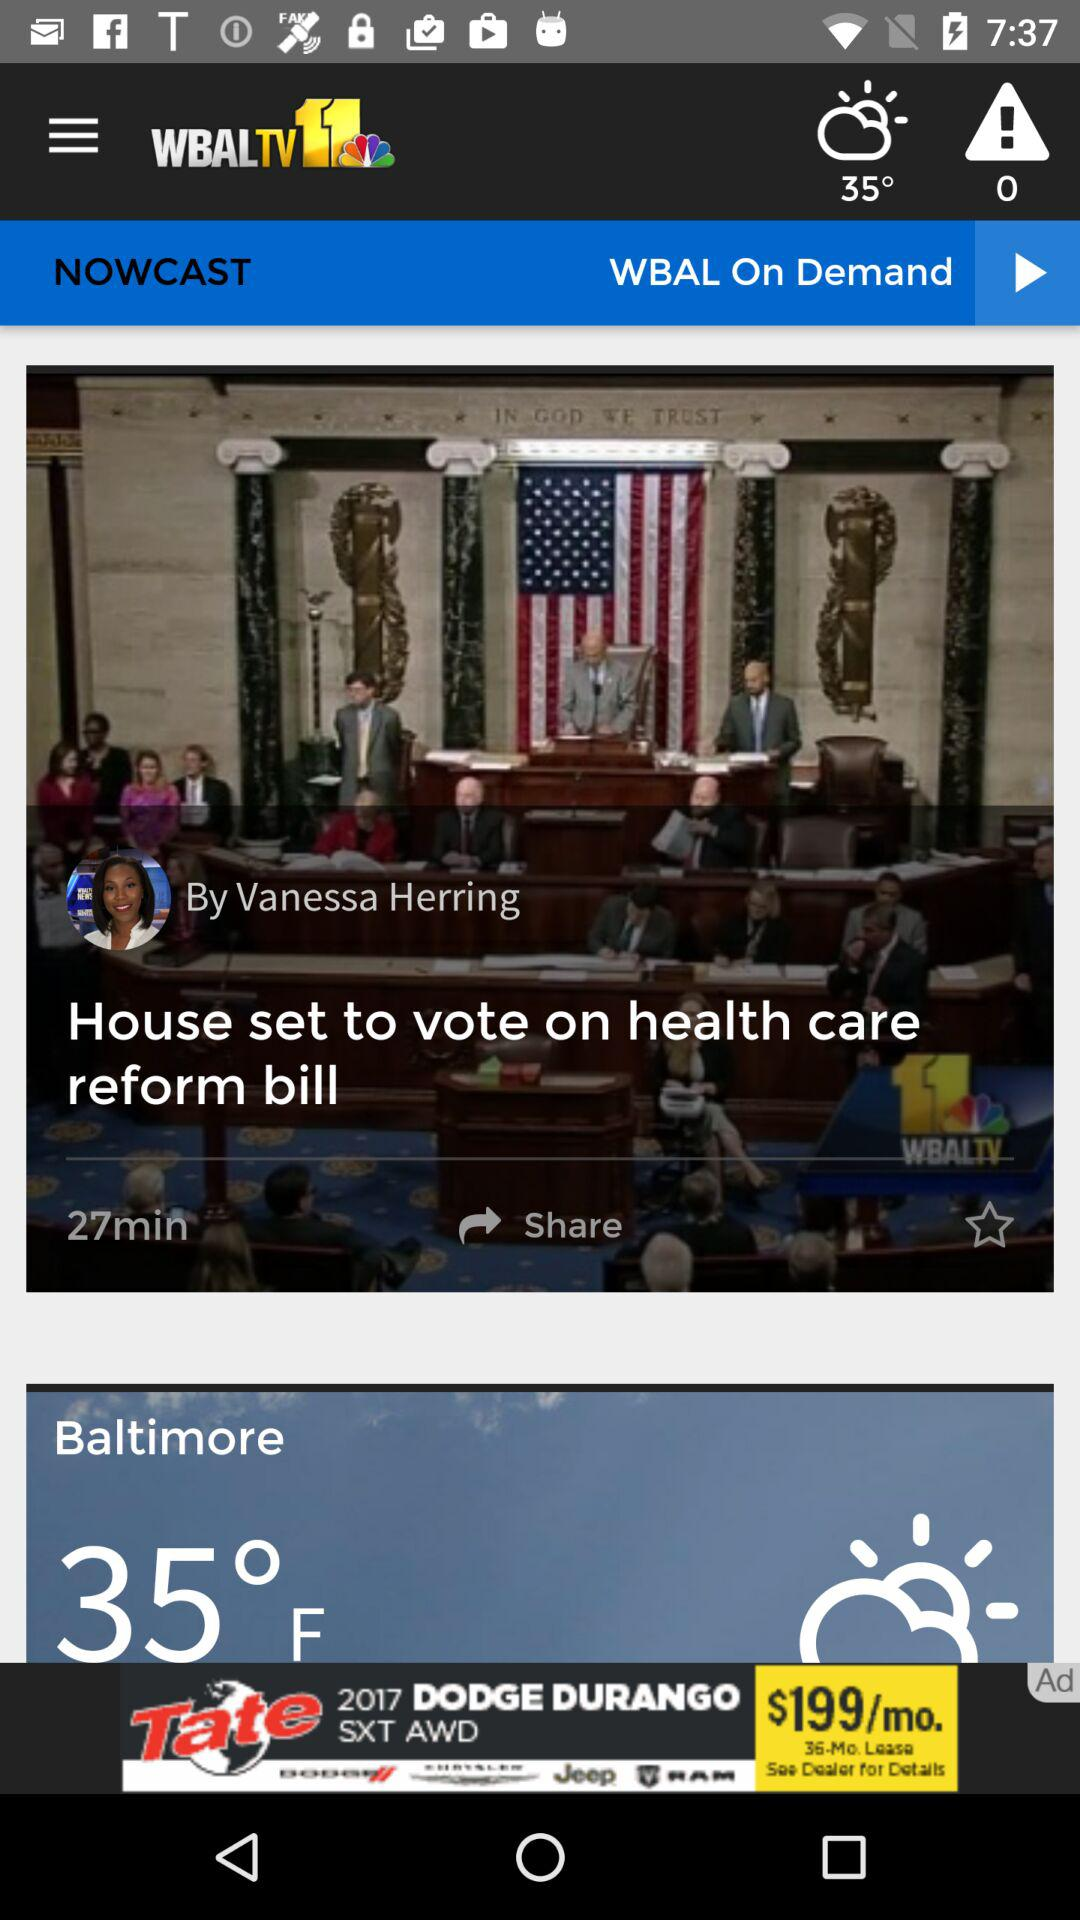Who posted "House set to vote on health care reform bill"? "House set to vote on health care reform bill" was posted by Vanessa Herring. 